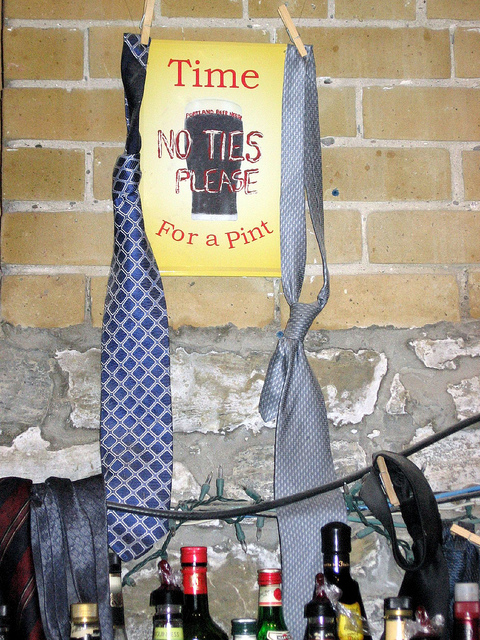Identify and read out the text in this image. Time TIES FOr a 